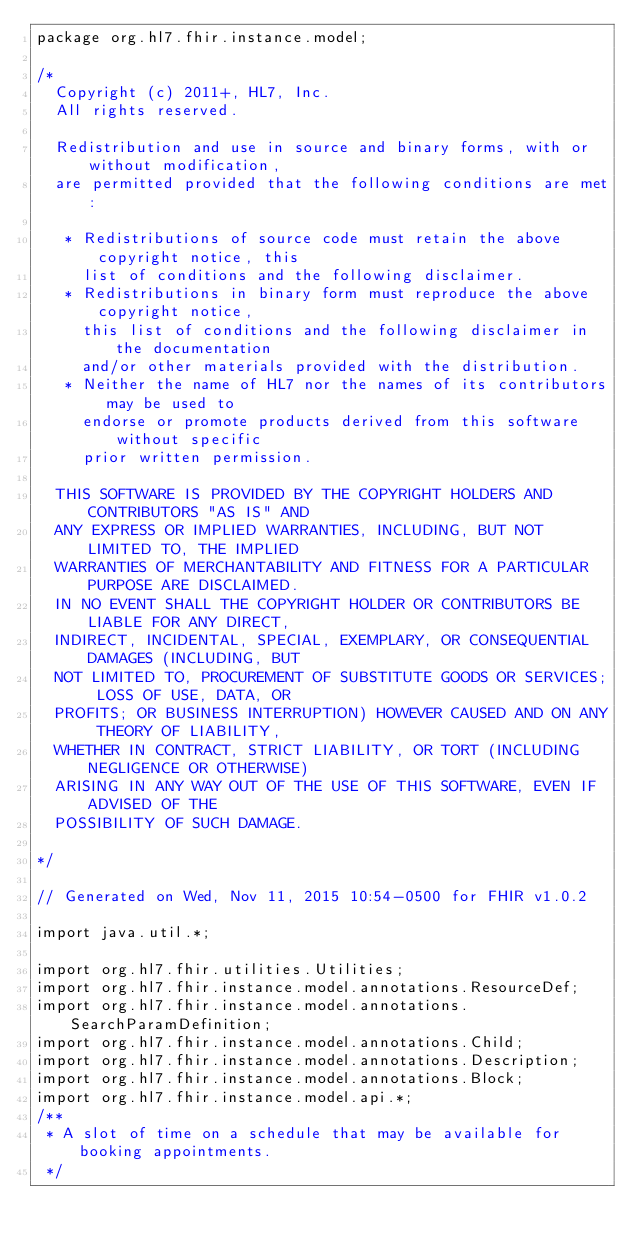Convert code to text. <code><loc_0><loc_0><loc_500><loc_500><_Java_>package org.hl7.fhir.instance.model;

/*
  Copyright (c) 2011+, HL7, Inc.
  All rights reserved.
  
  Redistribution and use in source and binary forms, with or without modification, 
  are permitted provided that the following conditions are met:
  
   * Redistributions of source code must retain the above copyright notice, this 
     list of conditions and the following disclaimer.
   * Redistributions in binary form must reproduce the above copyright notice, 
     this list of conditions and the following disclaimer in the documentation 
     and/or other materials provided with the distribution.
   * Neither the name of HL7 nor the names of its contributors may be used to 
     endorse or promote products derived from this software without specific 
     prior written permission.
  
  THIS SOFTWARE IS PROVIDED BY THE COPYRIGHT HOLDERS AND CONTRIBUTORS "AS IS" AND 
  ANY EXPRESS OR IMPLIED WARRANTIES, INCLUDING, BUT NOT LIMITED TO, THE IMPLIED 
  WARRANTIES OF MERCHANTABILITY AND FITNESS FOR A PARTICULAR PURPOSE ARE DISCLAIMED. 
  IN NO EVENT SHALL THE COPYRIGHT HOLDER OR CONTRIBUTORS BE LIABLE FOR ANY DIRECT, 
  INDIRECT, INCIDENTAL, SPECIAL, EXEMPLARY, OR CONSEQUENTIAL DAMAGES (INCLUDING, BUT 
  NOT LIMITED TO, PROCUREMENT OF SUBSTITUTE GOODS OR SERVICES; LOSS OF USE, DATA, OR 
  PROFITS; OR BUSINESS INTERRUPTION) HOWEVER CAUSED AND ON ANY THEORY OF LIABILITY, 
  WHETHER IN CONTRACT, STRICT LIABILITY, OR TORT (INCLUDING NEGLIGENCE OR OTHERWISE) 
  ARISING IN ANY WAY OUT OF THE USE OF THIS SOFTWARE, EVEN IF ADVISED OF THE 
  POSSIBILITY OF SUCH DAMAGE.
  
*/

// Generated on Wed, Nov 11, 2015 10:54-0500 for FHIR v1.0.2

import java.util.*;

import org.hl7.fhir.utilities.Utilities;
import org.hl7.fhir.instance.model.annotations.ResourceDef;
import org.hl7.fhir.instance.model.annotations.SearchParamDefinition;
import org.hl7.fhir.instance.model.annotations.Child;
import org.hl7.fhir.instance.model.annotations.Description;
import org.hl7.fhir.instance.model.annotations.Block;
import org.hl7.fhir.instance.model.api.*;
/**
 * A slot of time on a schedule that may be available for booking appointments.
 */</code> 